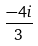Convert formula to latex. <formula><loc_0><loc_0><loc_500><loc_500>\frac { - 4 i } { 3 }</formula> 